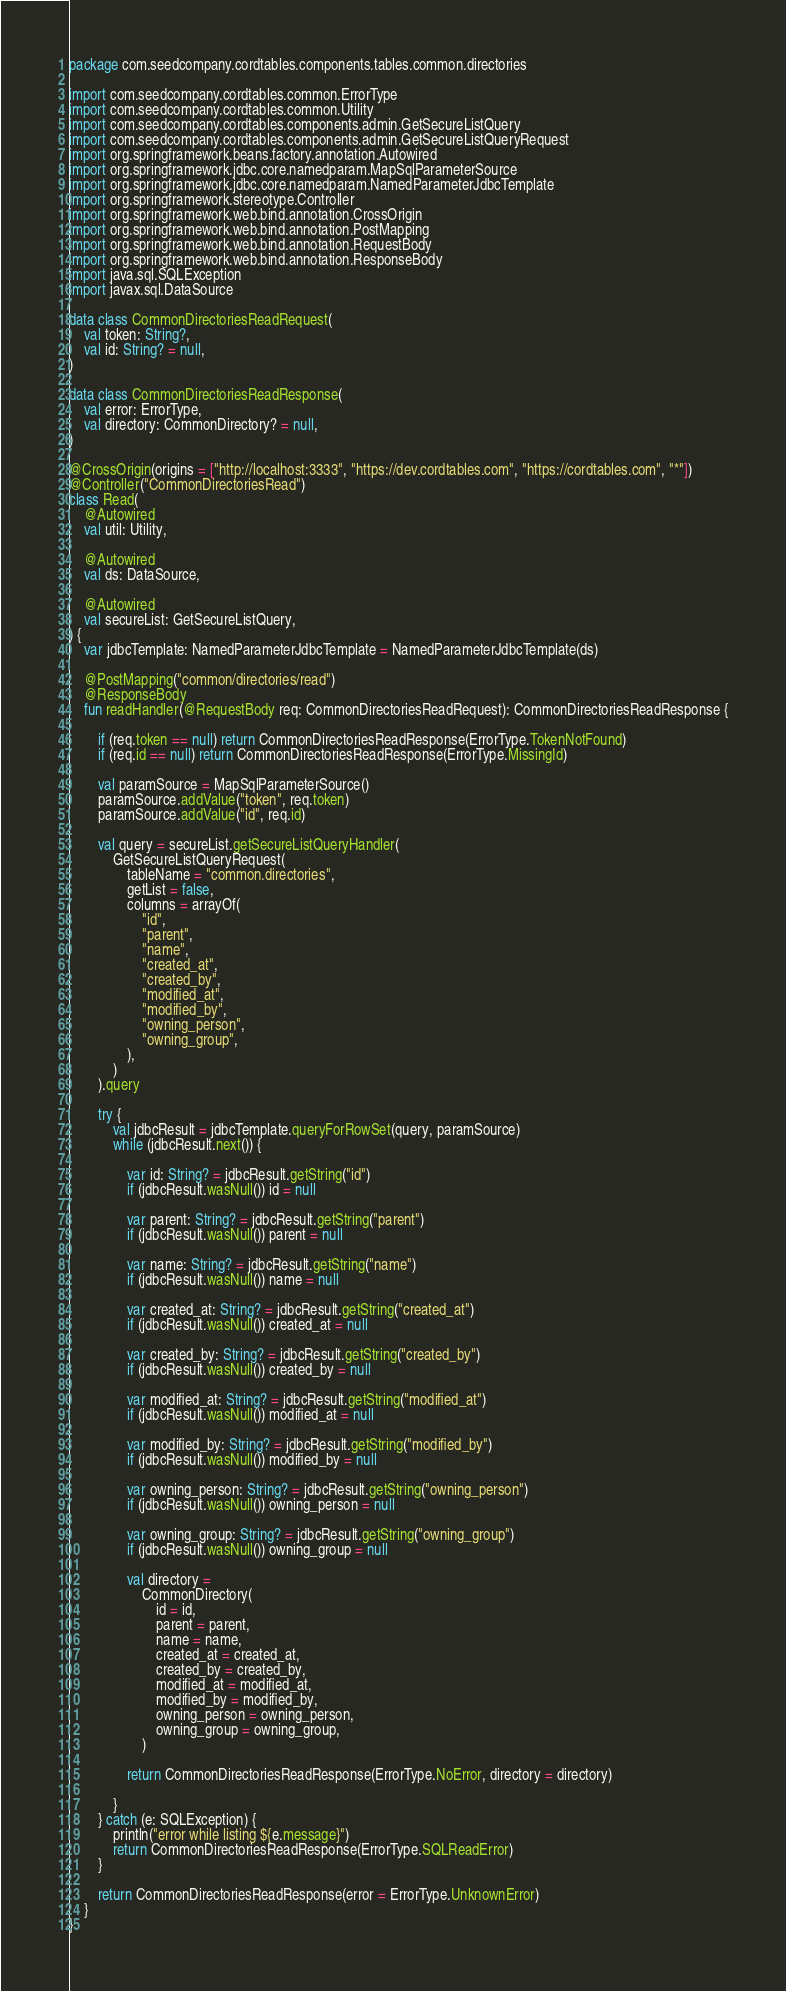<code> <loc_0><loc_0><loc_500><loc_500><_Kotlin_>package com.seedcompany.cordtables.components.tables.common.directories

import com.seedcompany.cordtables.common.ErrorType
import com.seedcompany.cordtables.common.Utility
import com.seedcompany.cordtables.components.admin.GetSecureListQuery
import com.seedcompany.cordtables.components.admin.GetSecureListQueryRequest
import org.springframework.beans.factory.annotation.Autowired
import org.springframework.jdbc.core.namedparam.MapSqlParameterSource
import org.springframework.jdbc.core.namedparam.NamedParameterJdbcTemplate
import org.springframework.stereotype.Controller
import org.springframework.web.bind.annotation.CrossOrigin
import org.springframework.web.bind.annotation.PostMapping
import org.springframework.web.bind.annotation.RequestBody
import org.springframework.web.bind.annotation.ResponseBody
import java.sql.SQLException
import javax.sql.DataSource

data class CommonDirectoriesReadRequest(
    val token: String?,
    val id: String? = null,
)

data class CommonDirectoriesReadResponse(
    val error: ErrorType,
    val directory: CommonDirectory? = null,
)

@CrossOrigin(origins = ["http://localhost:3333", "https://dev.cordtables.com", "https://cordtables.com", "*"])
@Controller("CommonDirectoriesRead")
class Read(
    @Autowired
    val util: Utility,

    @Autowired
    val ds: DataSource,

    @Autowired
    val secureList: GetSecureListQuery,
) {
    var jdbcTemplate: NamedParameterJdbcTemplate = NamedParameterJdbcTemplate(ds)

    @PostMapping("common/directories/read")
    @ResponseBody
    fun readHandler(@RequestBody req: CommonDirectoriesReadRequest): CommonDirectoriesReadResponse {

        if (req.token == null) return CommonDirectoriesReadResponse(ErrorType.TokenNotFound)
        if (req.id == null) return CommonDirectoriesReadResponse(ErrorType.MissingId)

        val paramSource = MapSqlParameterSource()
        paramSource.addValue("token", req.token)
        paramSource.addValue("id", req.id)

        val query = secureList.getSecureListQueryHandler(
            GetSecureListQueryRequest(
                tableName = "common.directories",
                getList = false,
                columns = arrayOf(
                    "id",
                    "parent",
                    "name",
                    "created_at",
                    "created_by",
                    "modified_at",
                    "modified_by",
                    "owning_person",
                    "owning_group",
                ),
            )
        ).query

        try {
            val jdbcResult = jdbcTemplate.queryForRowSet(query, paramSource)
            while (jdbcResult.next()) {

                var id: String? = jdbcResult.getString("id")
                if (jdbcResult.wasNull()) id = null

                var parent: String? = jdbcResult.getString("parent")
                if (jdbcResult.wasNull()) parent = null

                var name: String? = jdbcResult.getString("name")
                if (jdbcResult.wasNull()) name = null

                var created_at: String? = jdbcResult.getString("created_at")
                if (jdbcResult.wasNull()) created_at = null

                var created_by: String? = jdbcResult.getString("created_by")
                if (jdbcResult.wasNull()) created_by = null

                var modified_at: String? = jdbcResult.getString("modified_at")
                if (jdbcResult.wasNull()) modified_at = null

                var modified_by: String? = jdbcResult.getString("modified_by")
                if (jdbcResult.wasNull()) modified_by = null

                var owning_person: String? = jdbcResult.getString("owning_person")
                if (jdbcResult.wasNull()) owning_person = null

                var owning_group: String? = jdbcResult.getString("owning_group")
                if (jdbcResult.wasNull()) owning_group = null

                val directory =
                    CommonDirectory(
                        id = id,
                        parent = parent,
                        name = name,
                        created_at = created_at,
                        created_by = created_by,
                        modified_at = modified_at,
                        modified_by = modified_by,
                        owning_person = owning_person,
                        owning_group = owning_group,
                    )

                return CommonDirectoriesReadResponse(ErrorType.NoError, directory = directory)

            }
        } catch (e: SQLException) {
            println("error while listing ${e.message}")
            return CommonDirectoriesReadResponse(ErrorType.SQLReadError)
        }

        return CommonDirectoriesReadResponse(error = ErrorType.UnknownError)
    }
}
</code> 